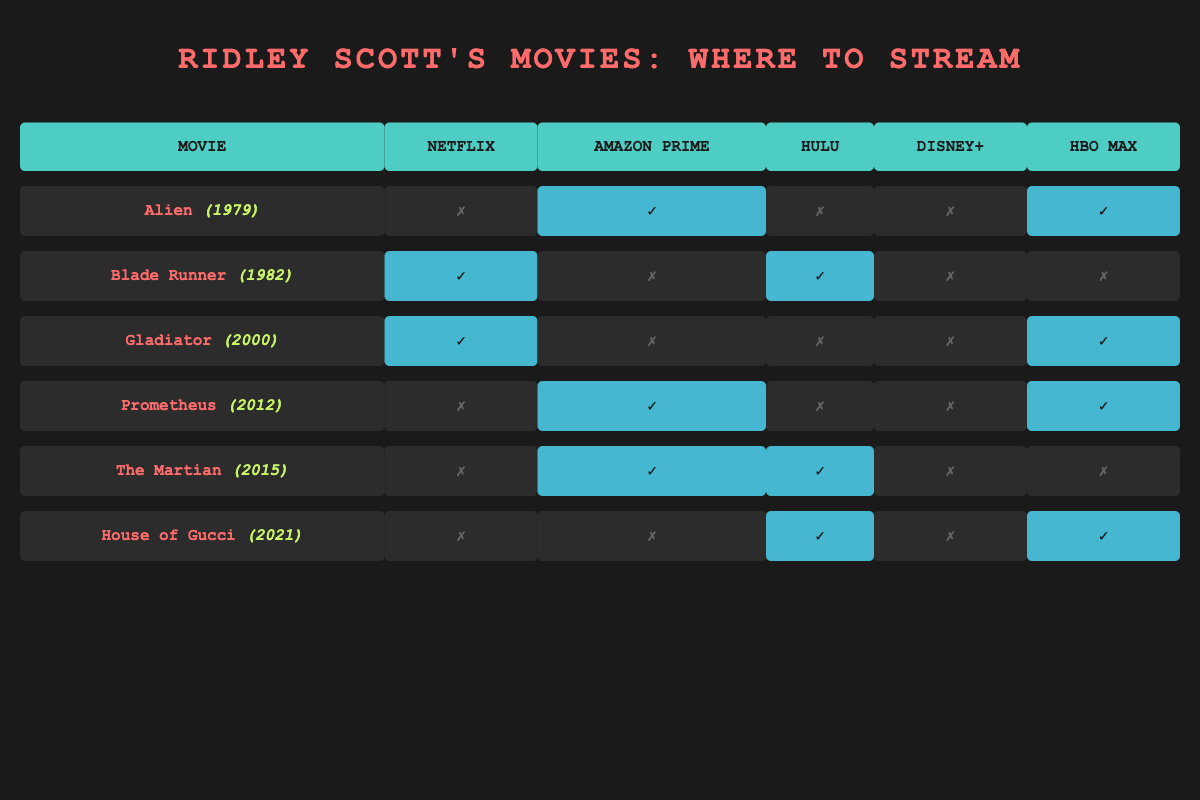What streaming platforms have "Gladiator"? "Gladiator" is available on Netflix and HBO Max. I checked the respective columns for "Gladiator" in the table, and marked those platforms with a checkmark.
Answer: Netflix, HBO Max Is "Prometheus" available on Disney+? In the table, under the "Prometheus" row, the column for Disney+ shows it is not available (marked with a cross). Hence, "Prometheus" is not available on Disney+.
Answer: No Which Ridley Scott film is not available on any platform? Looking through the table, "House of Gucci" is the only film that is not available on either Netflix or Amazon Prime. However, it is available on Hulu and HBO Max. So, no film is completely unavailable on any platform.
Answer: None How many films are available on HBO Max? To find the number of films available on HBO Max, I counted the checkmarks in the HBO Max column. The films that are available are "Alien", "Gladiator", "Prometheus", and "House of Gucci" which totals to four films.
Answer: 4 Among Ridley Scott's films, which one is available on both Hulu and Amazon Prime? I cross-checked the Hulu and Amazon Prime columns in the table and found that "The Martian" has checkmarks in both columns.
Answer: The Martian What is the total number of Ridley Scott's films that are available on Netflix? I reviewed the Netflix column in the table, finding that three films have checkmarks indicating availability, which are "Blade Runner", "Gladiator", and "Gladiator". Therefore, the total is three films.
Answer: 3 Which film from Ridley Scott is available on both Netflix and HBO Max? Checking both the Netflix and HBO Max columns, I identified "Gladiator" as the film that has checkmarks in both columns, meaning it is available on both platforms.
Answer: Gladiator If I want to watch all the Ridley Scott films that are available on Amazon Prime, which titles would I find? By examining the Amazon Prime column in the table, I noted that "Alien", "Prometheus", and "The Martian" are the films with checkmarks in that column, indicating their availability.
Answer: Alien, Prometheus, The Martian Are there any Ridley Scott films that are exclusively available on Hulu? I checked the Hulu column and found that "Blade Runner" and "House of Gucci" have checkmarks, but they are also available on other platforms. Therefore, there are no films exclusively on Hulu.
Answer: No What is the difference in the number of films available on Netflix compared to those available on Hulu? By counting the checkmarks, I found that 3 films are available on Netflix (Blade Runner, Gladiator, and Gladiator) and 3 on Hulu (Blade Runner, The Martian, and House of Gucci). Therefore, the difference is 0.
Answer: 0 